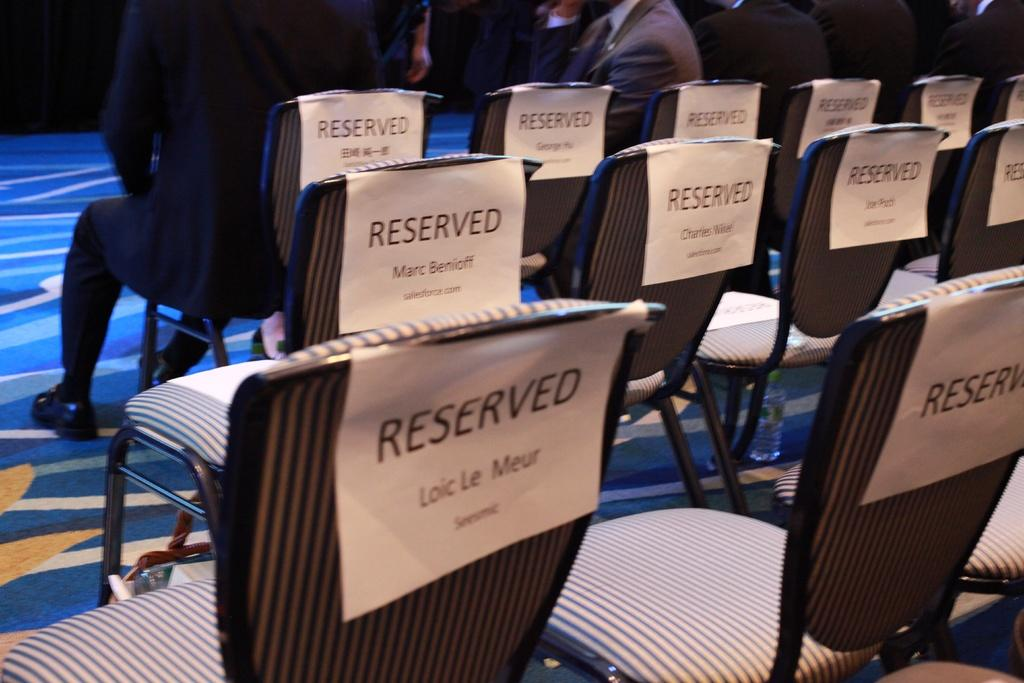Provide a one-sentence caption for the provided image. A collection of seats that all have reserved signs on them. 